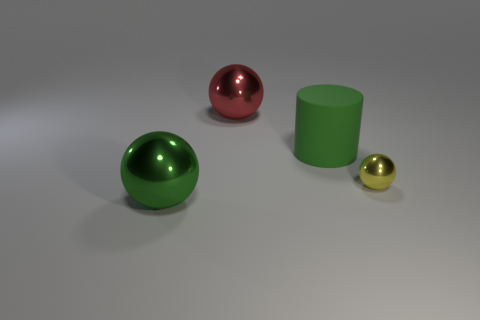The metallic object right of the object behind the big object that is to the right of the red metal object is what color?
Keep it short and to the point. Yellow. What number of shiny objects are either green things or small balls?
Make the answer very short. 2. Are there more balls that are behind the big red metallic ball than tiny yellow shiny objects that are on the left side of the tiny metallic thing?
Offer a terse response. No. What number of other objects are there of the same size as the red sphere?
Your answer should be very brief. 2. What size is the object on the left side of the large thing that is behind the big green cylinder?
Make the answer very short. Large. What number of big objects are either green metal balls or cyan rubber blocks?
Provide a short and direct response. 1. How big is the sphere to the right of the large shiny sphere that is behind the green thing that is to the left of the large red ball?
Your response must be concise. Small. Is there anything else that is the same color as the big cylinder?
Provide a succinct answer. Yes. There is a green object that is to the left of the big metallic object that is to the right of the green object in front of the small yellow sphere; what is its material?
Your answer should be compact. Metal. Is the small yellow metallic thing the same shape as the large green metallic object?
Your answer should be compact. Yes. 